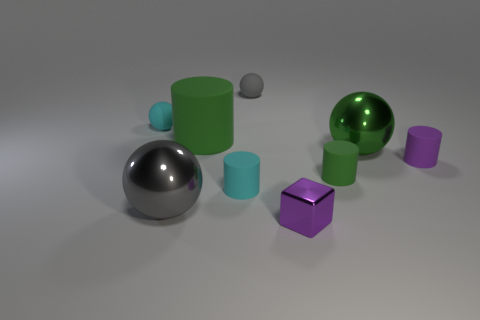Subtract all small green matte cylinders. How many cylinders are left? 3 Add 1 large yellow metallic things. How many objects exist? 10 Subtract all green balls. How many balls are left? 3 Subtract 3 cylinders. How many cylinders are left? 1 Add 2 green rubber things. How many green rubber things exist? 4 Subtract 0 purple spheres. How many objects are left? 9 Subtract all cylinders. How many objects are left? 5 Subtract all blue cubes. Subtract all red balls. How many cubes are left? 1 Subtract all green cubes. How many gray cylinders are left? 0 Subtract all gray metallic balls. Subtract all tiny cyan cylinders. How many objects are left? 7 